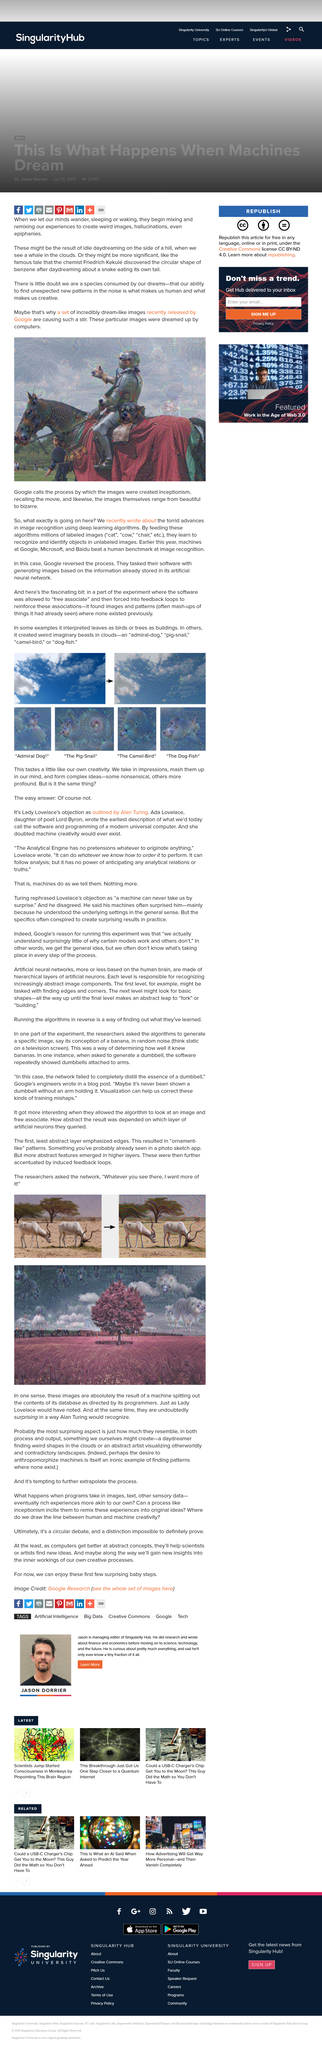Specify some key components in this picture. Google recently released dream-like images that were created through the process called inceptionism. Benzene is a circular shape. Human creativity and machine creativity are not similar, as declared by Alan Turing in his objection outlined in "Lady Lovelace's Objection. The researcher asked the network to provide more of whatever it was showing. In the first picture, I perceive two gazelles. 